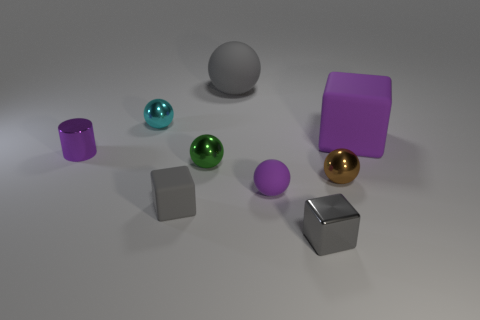What size is the matte ball that is the same color as the cylinder?
Offer a terse response. Small. There is a rubber block right of the large gray rubber sphere; is it the same color as the matte sphere in front of the small metal cylinder?
Your response must be concise. Yes. How many things are either small brown things or small cyan cylinders?
Give a very brief answer. 1. How many other objects are there of the same shape as the big purple object?
Offer a terse response. 2. Is the material of the small cube that is left of the large gray rubber ball the same as the gray thing that is behind the green shiny sphere?
Make the answer very short. Yes. There is a purple object that is behind the small purple sphere and to the right of the large gray matte thing; what is its shape?
Ensure brevity in your answer.  Cube. What is the material of the small thing that is both right of the small metallic cylinder and left of the small gray matte cube?
Make the answer very short. Metal. What is the shape of the gray object that is the same material as the tiny green object?
Offer a terse response. Cube. Is there any other thing that is the same color as the tiny cylinder?
Your answer should be very brief. Yes. Are there more gray matte objects behind the brown thing than large brown metal spheres?
Make the answer very short. Yes. 